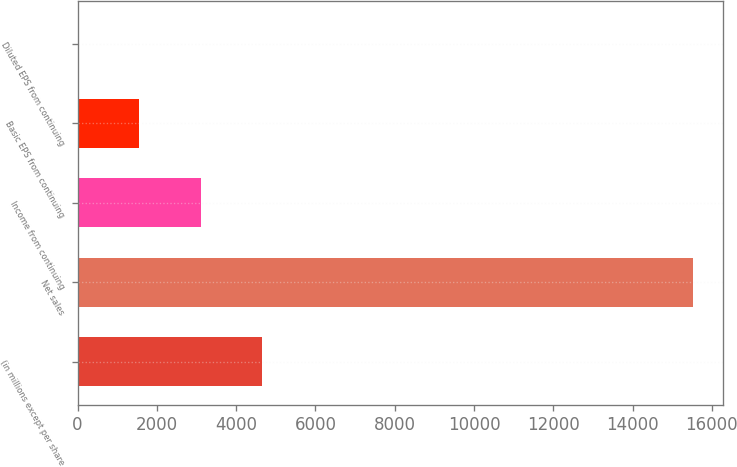<chart> <loc_0><loc_0><loc_500><loc_500><bar_chart><fcel>(in millions except per share<fcel>Net sales<fcel>Income from continuing<fcel>Basic EPS from continuing<fcel>Diluted EPS from continuing<nl><fcel>4656.38<fcel>15513<fcel>3105.44<fcel>1554.5<fcel>3.56<nl></chart> 